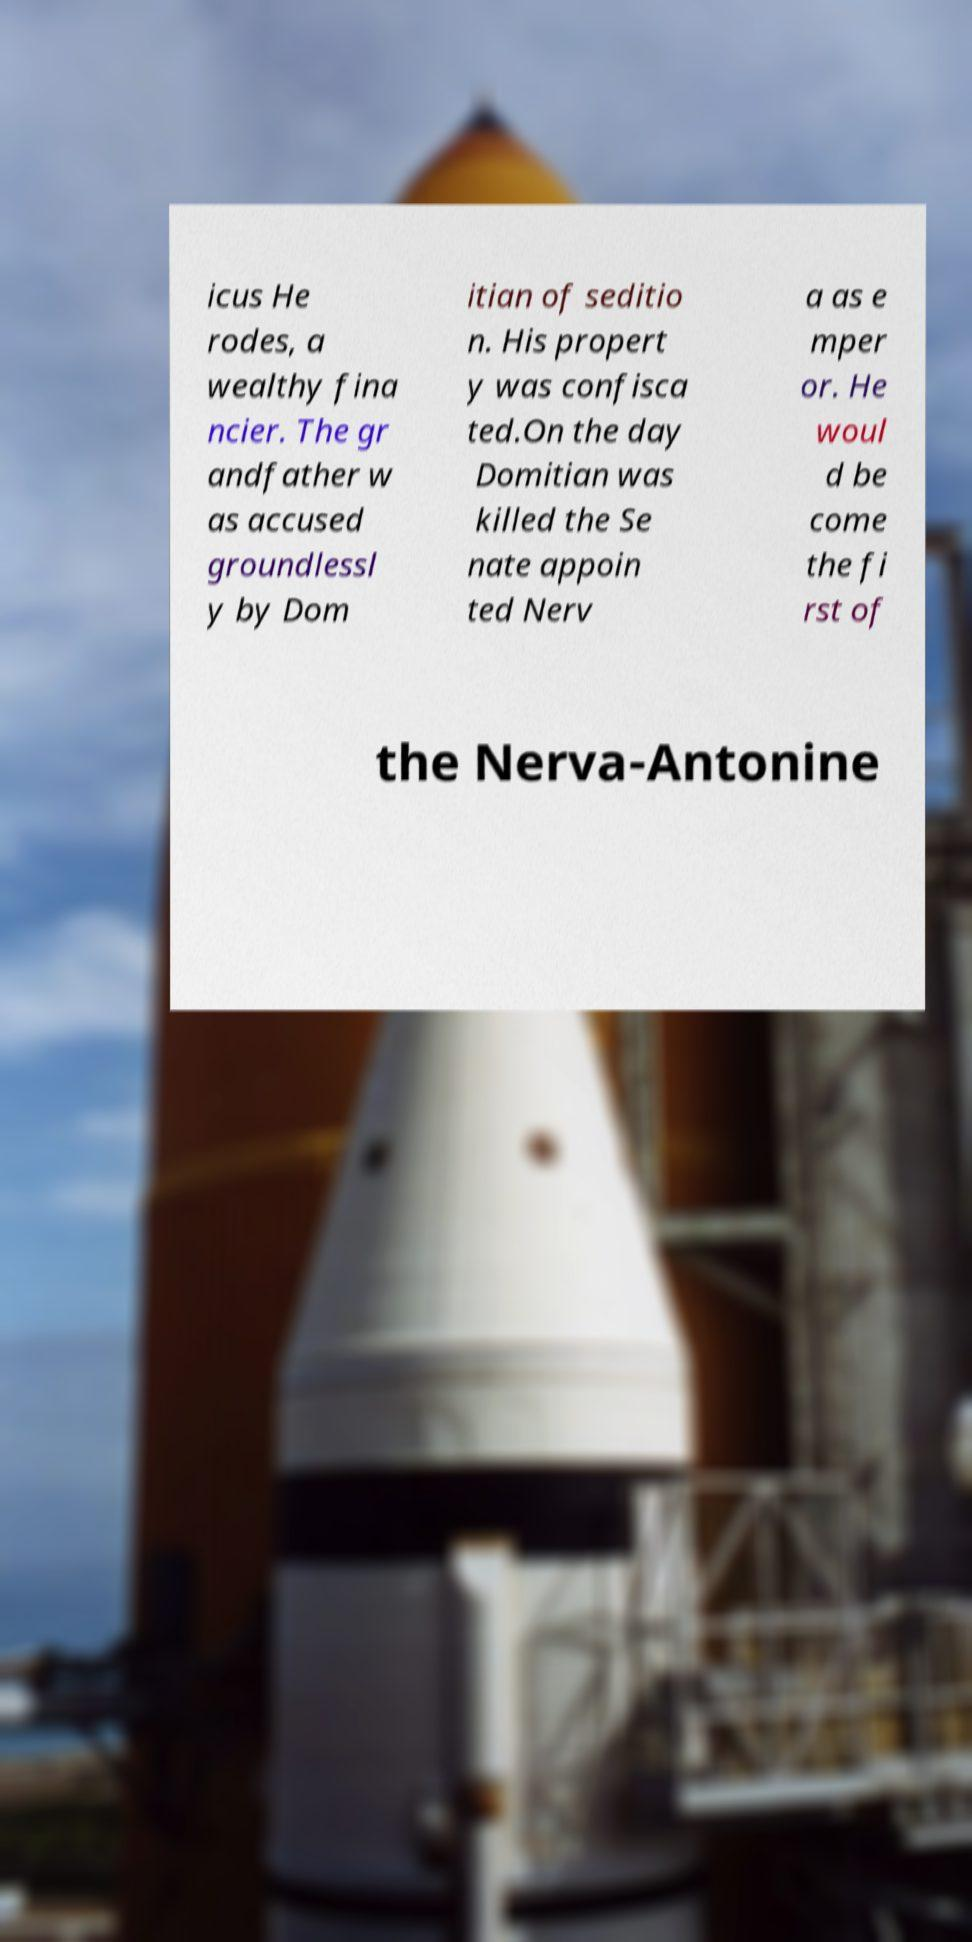For documentation purposes, I need the text within this image transcribed. Could you provide that? icus He rodes, a wealthy fina ncier. The gr andfather w as accused groundlessl y by Dom itian of seditio n. His propert y was confisca ted.On the day Domitian was killed the Se nate appoin ted Nerv a as e mper or. He woul d be come the fi rst of the Nerva-Antonine 